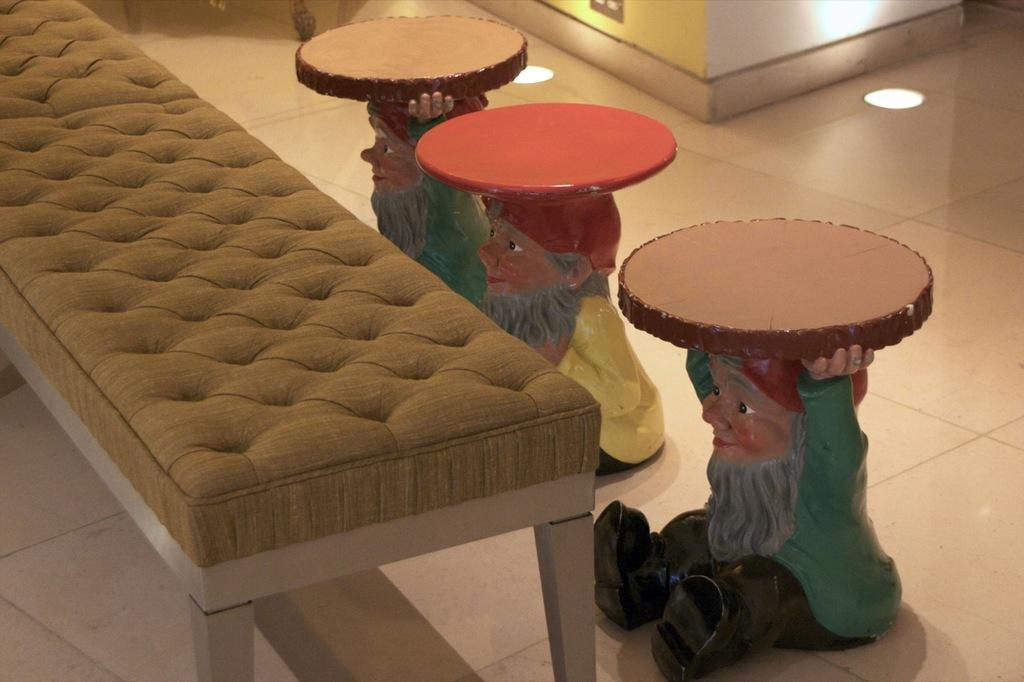What type of furniture is in the image? There is a sofa in the image. What other seating objects are present in the image? There are three stools on the floor in front of the sofa. What type of plastic material is covering the sofa in the image? There is no mention of any plastic material covering the sofa in the image. How many leaves are visible on the stools in the image? There is no mention of any leaves on the stools or any other objects in the image. 